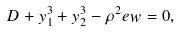<formula> <loc_0><loc_0><loc_500><loc_500>D + y _ { 1 } ^ { 3 } + y _ { 2 } ^ { 3 } - \rho ^ { 2 } e w = 0 ,</formula> 